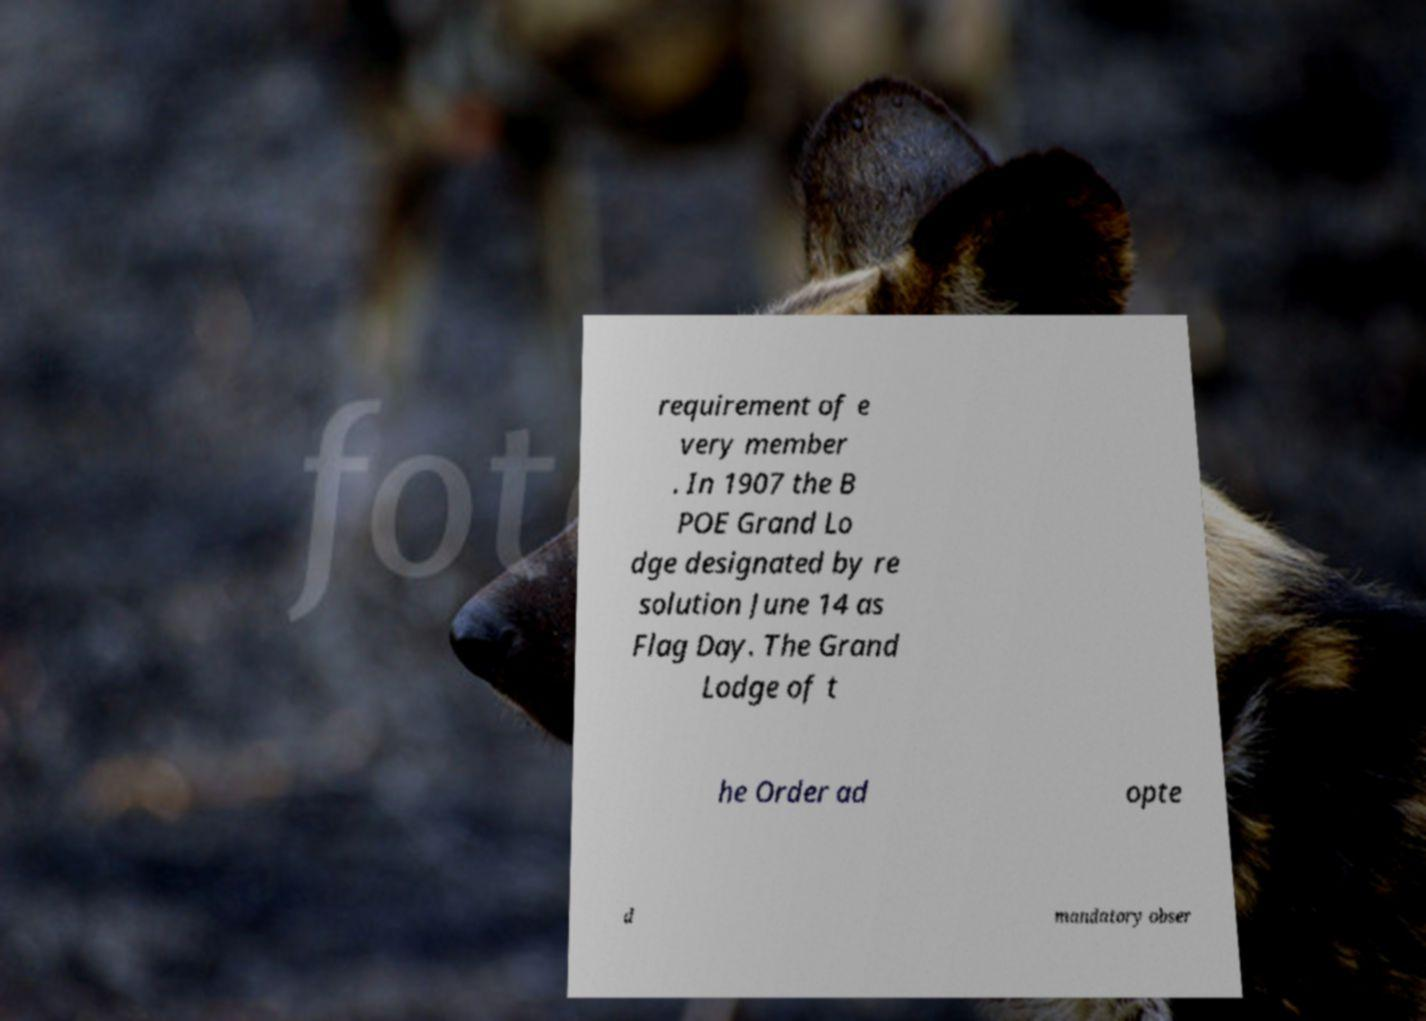I need the written content from this picture converted into text. Can you do that? requirement of e very member . In 1907 the B POE Grand Lo dge designated by re solution June 14 as Flag Day. The Grand Lodge of t he Order ad opte d mandatory obser 